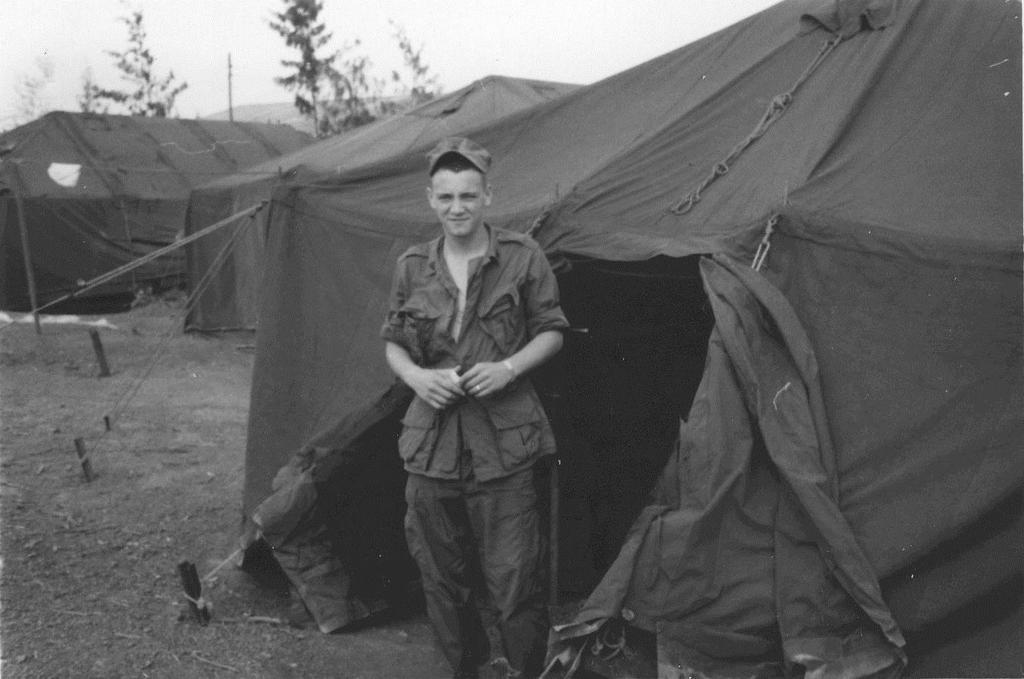What type of temporary shelter can be seen in the image? There are tents in the image. What natural elements are present in the image? There are trees in the image. Can you describe the person in the image? The person is standing and wearing a cap. What is the weather like in the image? The sky is cloudy in the image. How many flocks of powder are visible on the bed in the image? There is no bed or flocks of powder present in the image. What type of creature is interacting with the tents in the image? There is no creature interacting with the tents in the image; only the person wearing a cap is visible. 